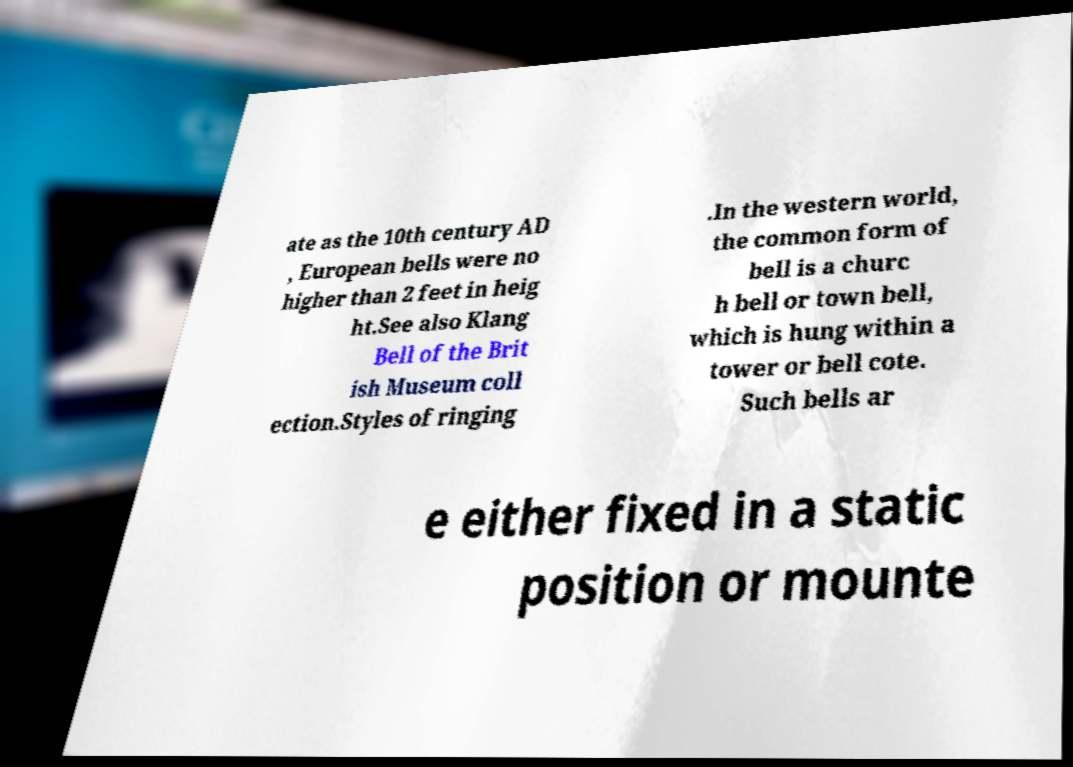Can you read and provide the text displayed in the image?This photo seems to have some interesting text. Can you extract and type it out for me? ate as the 10th century AD , European bells were no higher than 2 feet in heig ht.See also Klang Bell of the Brit ish Museum coll ection.Styles of ringing .In the western world, the common form of bell is a churc h bell or town bell, which is hung within a tower or bell cote. Such bells ar e either fixed in a static position or mounte 